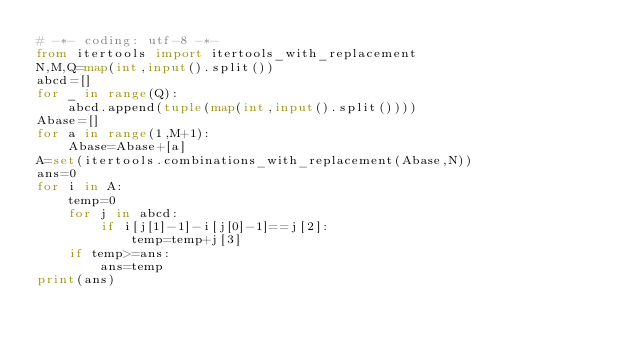<code> <loc_0><loc_0><loc_500><loc_500><_Python_># -*- coding: utf-8 -*-
from itertools import itertools_with_replacement
N,M,Q=map(int,input().split())
abcd=[]
for _ in range(Q):
    abcd.append(tuple(map(int,input().split())))
Abase=[]
for a in range(1,M+1):
    Abase=Abase+[a]
A=set(itertools.combinations_with_replacement(Abase,N))
ans=0
for i in A:
    temp=0
    for j in abcd:
        if i[j[1]-1]-i[j[0]-1]==j[2]:
            temp=temp+j[3]
    if temp>=ans:
        ans=temp
print(ans)</code> 